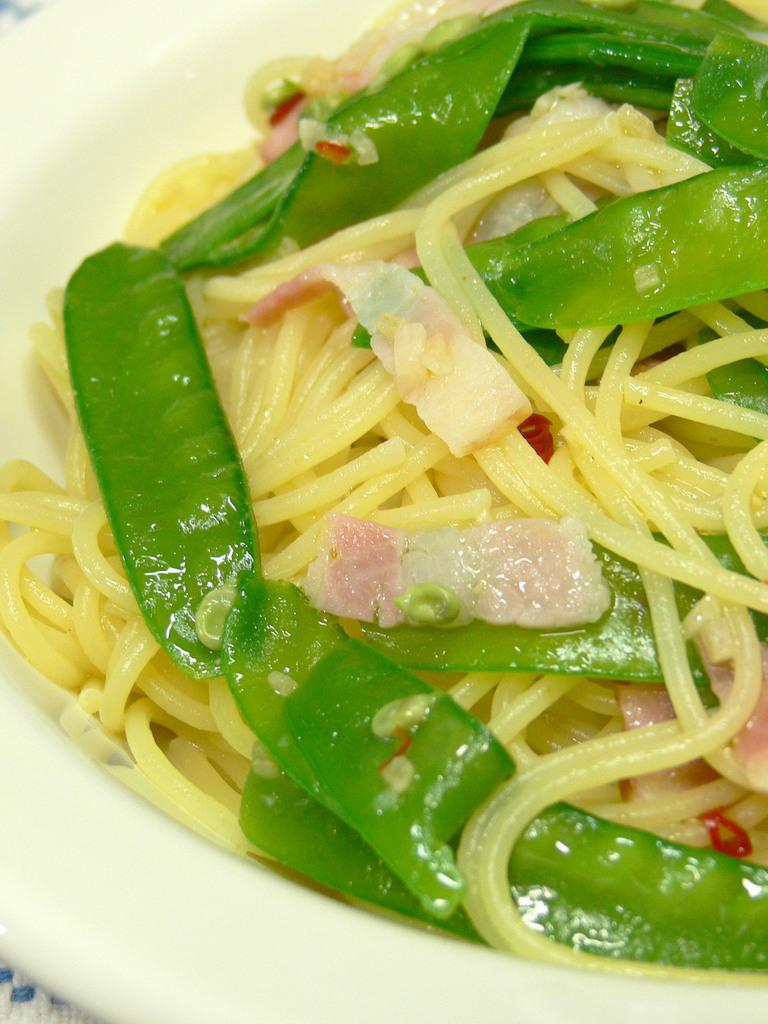What color is the plate in the image? The plate in the image is white. What is on the plate? There are cream color noodles on the plate. What other colors can be seen in the ingredients of the dish? There are green and cream color ingredients in the image. What way do the noodles start to believe in the image? The noodles do not have beliefs or a way to start believing in the image; they are simply a food item on a plate. 